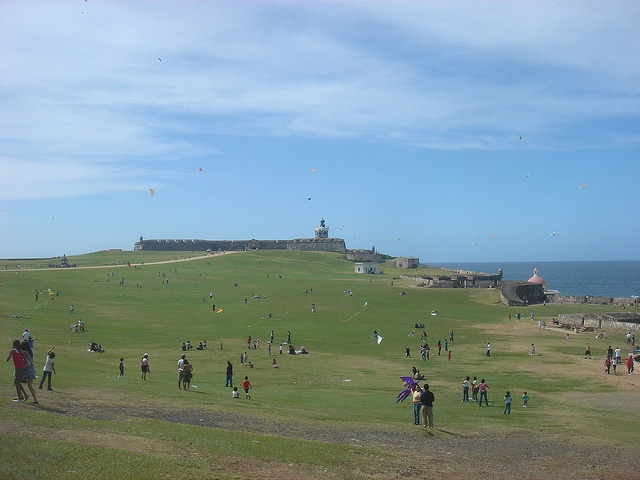Describe the objects in this image and their specific colors. I can see people in lavender, gray, black, and darkgreen tones, kite in lavender, lightblue, and darkgreen tones, people in lavender, black, gray, and darkblue tones, people in lavender, gray, black, darkgreen, and darkgray tones, and people in lavender, black, gray, and darkgreen tones in this image. 